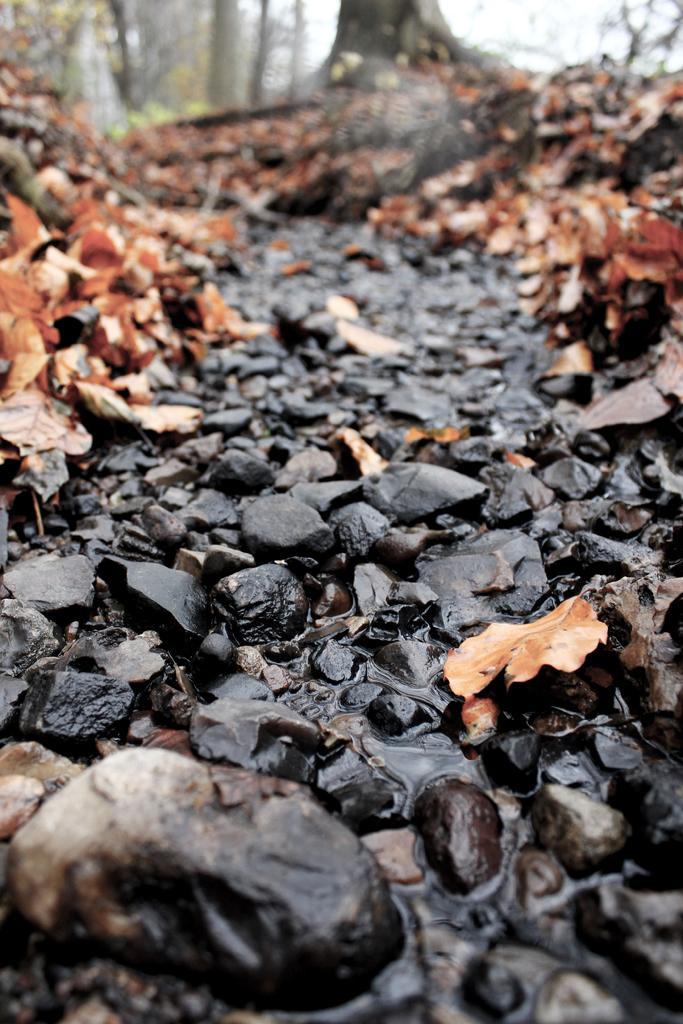Describe this image in one or two sentences. In the picture we can see a path with black colored stones and some water flowing from it and besides, we can see dried leaves and in the background we can see trees and sky. 